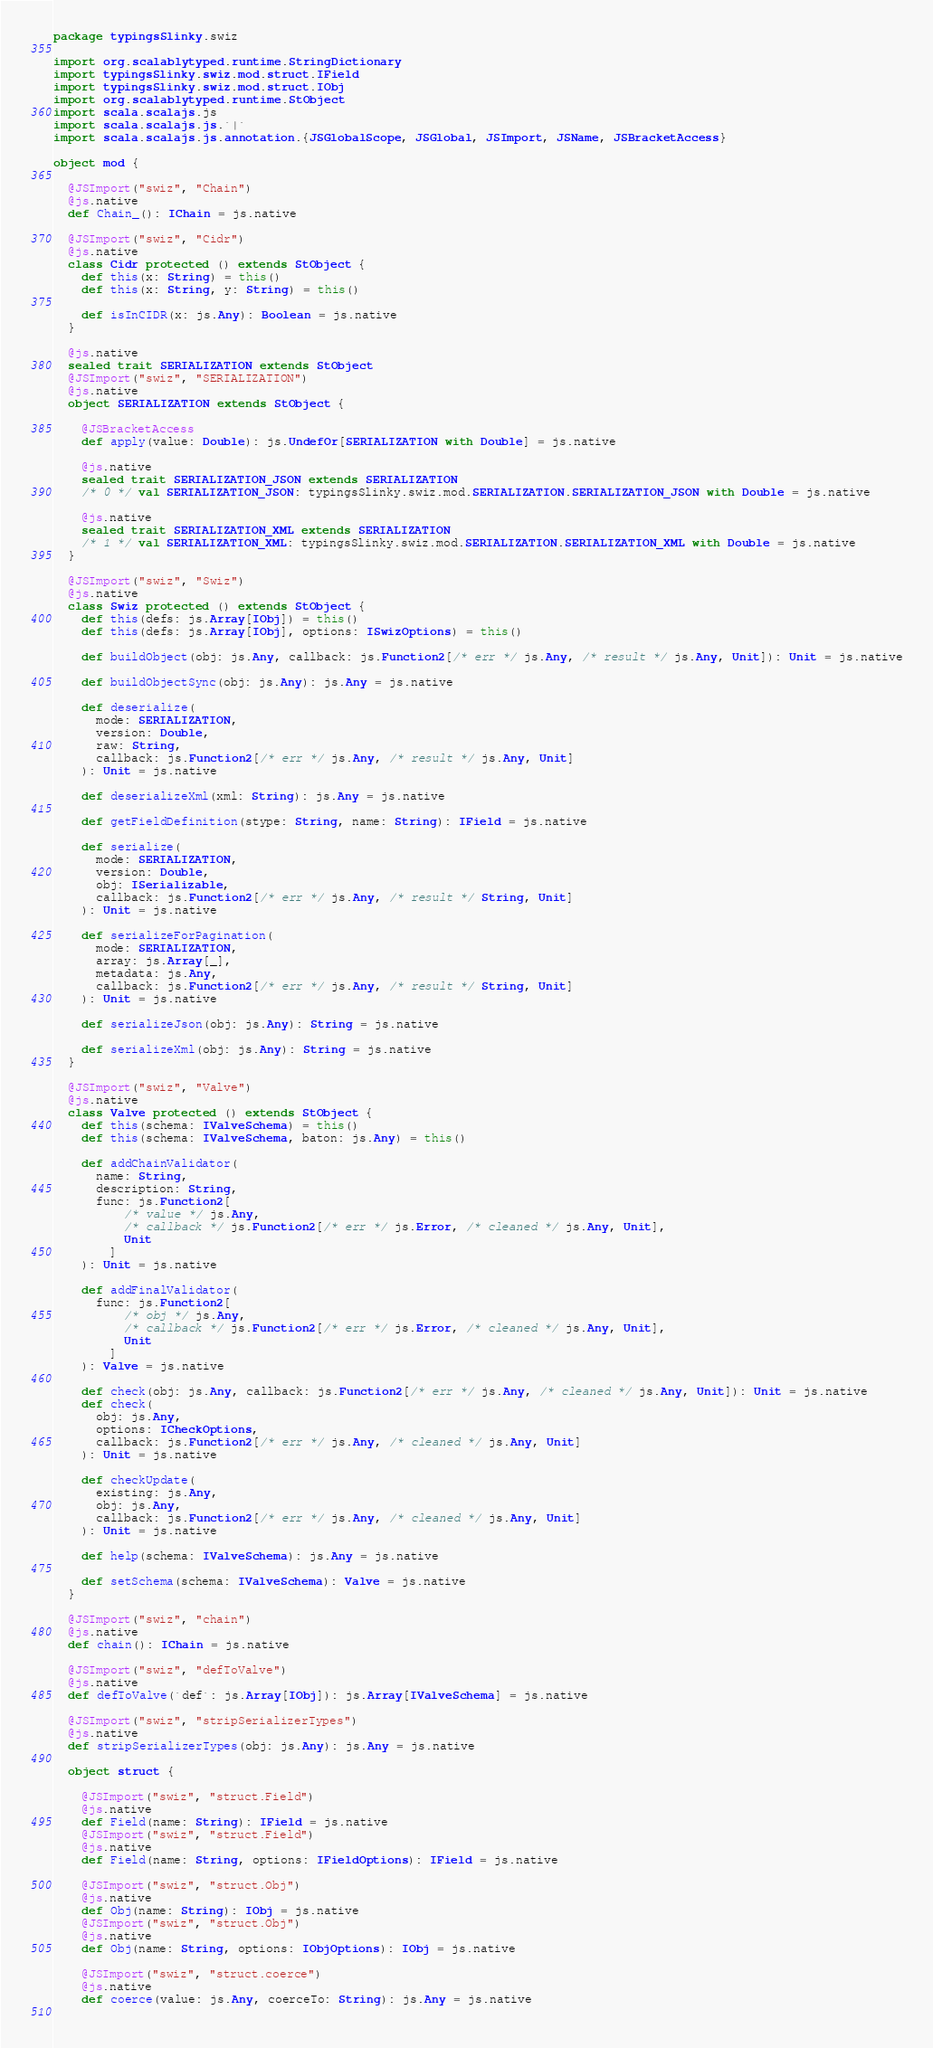<code> <loc_0><loc_0><loc_500><loc_500><_Scala_>package typingsSlinky.swiz

import org.scalablytyped.runtime.StringDictionary
import typingsSlinky.swiz.mod.struct.IField
import typingsSlinky.swiz.mod.struct.IObj
import org.scalablytyped.runtime.StObject
import scala.scalajs.js
import scala.scalajs.js.`|`
import scala.scalajs.js.annotation.{JSGlobalScope, JSGlobal, JSImport, JSName, JSBracketAccess}

object mod {
  
  @JSImport("swiz", "Chain")
  @js.native
  def Chain_(): IChain = js.native
  
  @JSImport("swiz", "Cidr")
  @js.native
  class Cidr protected () extends StObject {
    def this(x: String) = this()
    def this(x: String, y: String) = this()
    
    def isInCIDR(x: js.Any): Boolean = js.native
  }
  
  @js.native
  sealed trait SERIALIZATION extends StObject
  @JSImport("swiz", "SERIALIZATION")
  @js.native
  object SERIALIZATION extends StObject {
    
    @JSBracketAccess
    def apply(value: Double): js.UndefOr[SERIALIZATION with Double] = js.native
    
    @js.native
    sealed trait SERIALIZATION_JSON extends SERIALIZATION
    /* 0 */ val SERIALIZATION_JSON: typingsSlinky.swiz.mod.SERIALIZATION.SERIALIZATION_JSON with Double = js.native
    
    @js.native
    sealed trait SERIALIZATION_XML extends SERIALIZATION
    /* 1 */ val SERIALIZATION_XML: typingsSlinky.swiz.mod.SERIALIZATION.SERIALIZATION_XML with Double = js.native
  }
  
  @JSImport("swiz", "Swiz")
  @js.native
  class Swiz protected () extends StObject {
    def this(defs: js.Array[IObj]) = this()
    def this(defs: js.Array[IObj], options: ISwizOptions) = this()
    
    def buildObject(obj: js.Any, callback: js.Function2[/* err */ js.Any, /* result */ js.Any, Unit]): Unit = js.native
    
    def buildObjectSync(obj: js.Any): js.Any = js.native
    
    def deserialize(
      mode: SERIALIZATION,
      version: Double,
      raw: String,
      callback: js.Function2[/* err */ js.Any, /* result */ js.Any, Unit]
    ): Unit = js.native
    
    def deserializeXml(xml: String): js.Any = js.native
    
    def getFieldDefinition(stype: String, name: String): IField = js.native
    
    def serialize(
      mode: SERIALIZATION,
      version: Double,
      obj: ISerializable,
      callback: js.Function2[/* err */ js.Any, /* result */ String, Unit]
    ): Unit = js.native
    
    def serializeForPagination(
      mode: SERIALIZATION,
      array: js.Array[_],
      metadata: js.Any,
      callback: js.Function2[/* err */ js.Any, /* result */ String, Unit]
    ): Unit = js.native
    
    def serializeJson(obj: js.Any): String = js.native
    
    def serializeXml(obj: js.Any): String = js.native
  }
  
  @JSImport("swiz", "Valve")
  @js.native
  class Valve protected () extends StObject {
    def this(schema: IValveSchema) = this()
    def this(schema: IValveSchema, baton: js.Any) = this()
    
    def addChainValidator(
      name: String,
      description: String,
      func: js.Function2[
          /* value */ js.Any, 
          /* callback */ js.Function2[/* err */ js.Error, /* cleaned */ js.Any, Unit], 
          Unit
        ]
    ): Unit = js.native
    
    def addFinalValidator(
      func: js.Function2[
          /* obj */ js.Any, 
          /* callback */ js.Function2[/* err */ js.Error, /* cleaned */ js.Any, Unit], 
          Unit
        ]
    ): Valve = js.native
    
    def check(obj: js.Any, callback: js.Function2[/* err */ js.Any, /* cleaned */ js.Any, Unit]): Unit = js.native
    def check(
      obj: js.Any,
      options: ICheckOptions,
      callback: js.Function2[/* err */ js.Any, /* cleaned */ js.Any, Unit]
    ): Unit = js.native
    
    def checkUpdate(
      existing: js.Any,
      obj: js.Any,
      callback: js.Function2[/* err */ js.Any, /* cleaned */ js.Any, Unit]
    ): Unit = js.native
    
    def help(schema: IValveSchema): js.Any = js.native
    
    def setSchema(schema: IValveSchema): Valve = js.native
  }
  
  @JSImport("swiz", "chain")
  @js.native
  def chain(): IChain = js.native
  
  @JSImport("swiz", "defToValve")
  @js.native
  def defToValve(`def`: js.Array[IObj]): js.Array[IValveSchema] = js.native
  
  @JSImport("swiz", "stripSerializerTypes")
  @js.native
  def stripSerializerTypes(obj: js.Any): js.Any = js.native
  
  object struct {
    
    @JSImport("swiz", "struct.Field")
    @js.native
    def Field(name: String): IField = js.native
    @JSImport("swiz", "struct.Field")
    @js.native
    def Field(name: String, options: IFieldOptions): IField = js.native
    
    @JSImport("swiz", "struct.Obj")
    @js.native
    def Obj(name: String): IObj = js.native
    @JSImport("swiz", "struct.Obj")
    @js.native
    def Obj(name: String, options: IObjOptions): IObj = js.native
    
    @JSImport("swiz", "struct.coerce")
    @js.native
    def coerce(value: js.Any, coerceTo: String): js.Any = js.native
    </code> 